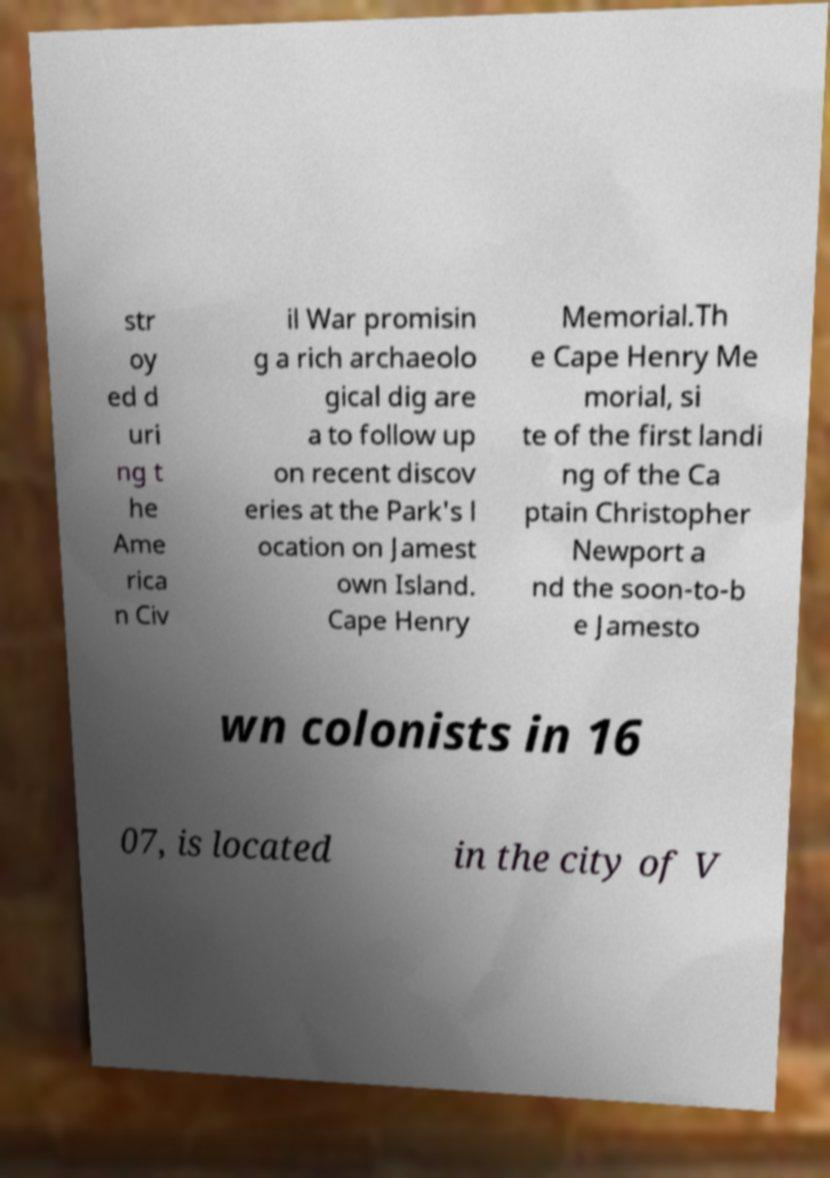For documentation purposes, I need the text within this image transcribed. Could you provide that? str oy ed d uri ng t he Ame rica n Civ il War promisin g a rich archaeolo gical dig are a to follow up on recent discov eries at the Park's l ocation on Jamest own Island. Cape Henry Memorial.Th e Cape Henry Me morial, si te of the first landi ng of the Ca ptain Christopher Newport a nd the soon-to-b e Jamesto wn colonists in 16 07, is located in the city of V 